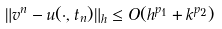<formula> <loc_0><loc_0><loc_500><loc_500>\| v ^ { n } - u ( \cdot , t _ { n } ) \| _ { h } \leq O ( h ^ { p _ { 1 } } + k ^ { p _ { 2 } } )</formula> 